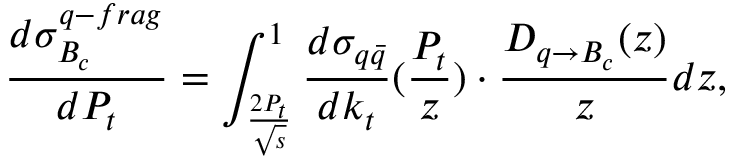Convert formula to latex. <formula><loc_0><loc_0><loc_500><loc_500>\frac { d \sigma _ { B _ { c } } ^ { q - f r a g } } { d P _ { t } } = \int _ { \frac { 2 P _ { t } } { \sqrt { s } } } ^ { 1 } \frac { d \sigma _ { q \bar { q } } } { d k _ { t } } ( \frac { P _ { t } } { z } ) \cdot \frac { D _ { q \rightarrow B _ { c } } ( z ) } { z } d z ,</formula> 